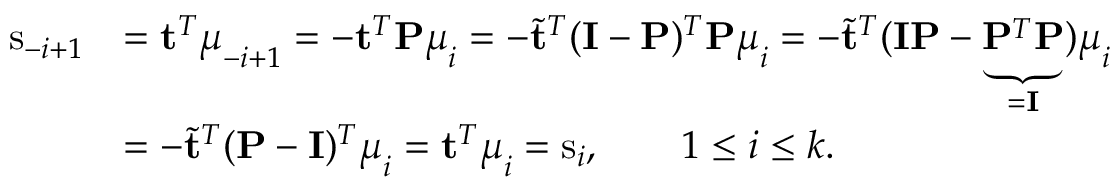<formula> <loc_0><loc_0><loc_500><loc_500>\begin{array} { r l } { s _ { - i + 1 } } & { = t ^ { T } \mu _ { - i + 1 } = - t ^ { T } P \mu _ { i } = - \tilde { t } ^ { T } ( I - P ) ^ { T } P \mu _ { i } = - \tilde { t } ^ { T } ( I P - \underbrace { P ^ { T } P } _ { = I } ) \mu _ { i } } \\ & { = - \tilde { t } ^ { T } ( P - I ) ^ { T } \mu _ { i } = t ^ { T } \mu _ { i } = s _ { i } , \quad 1 \leq i \leq k . } \end{array}</formula> 